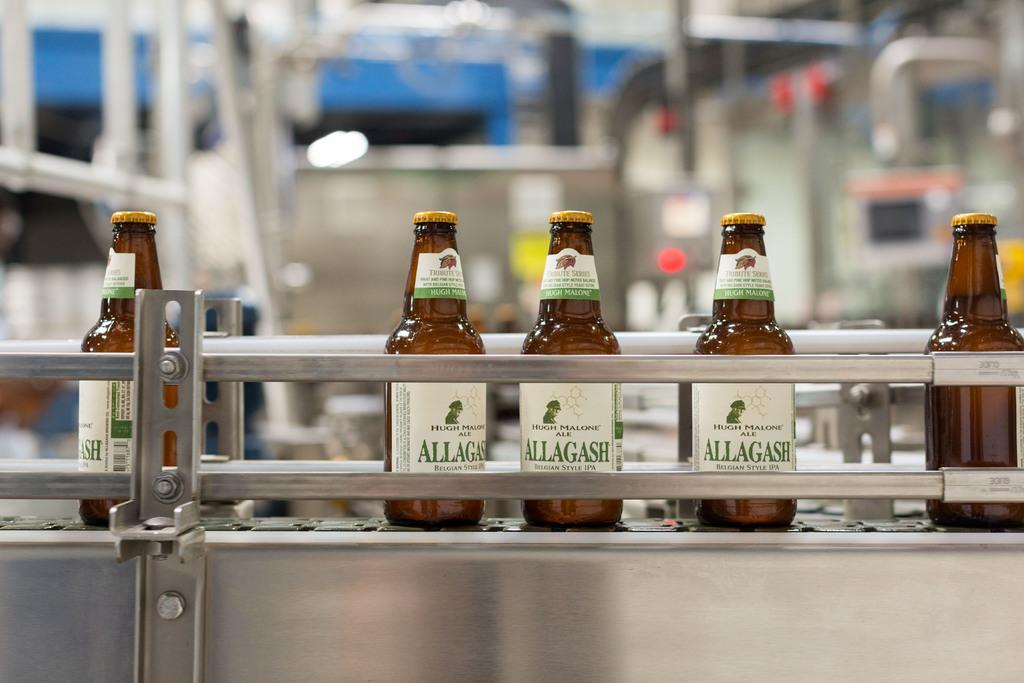<image>
Give a short and clear explanation of the subsequent image. Bottles of Allagash Hugh Malone Ale, a Belgian-style IPA. 